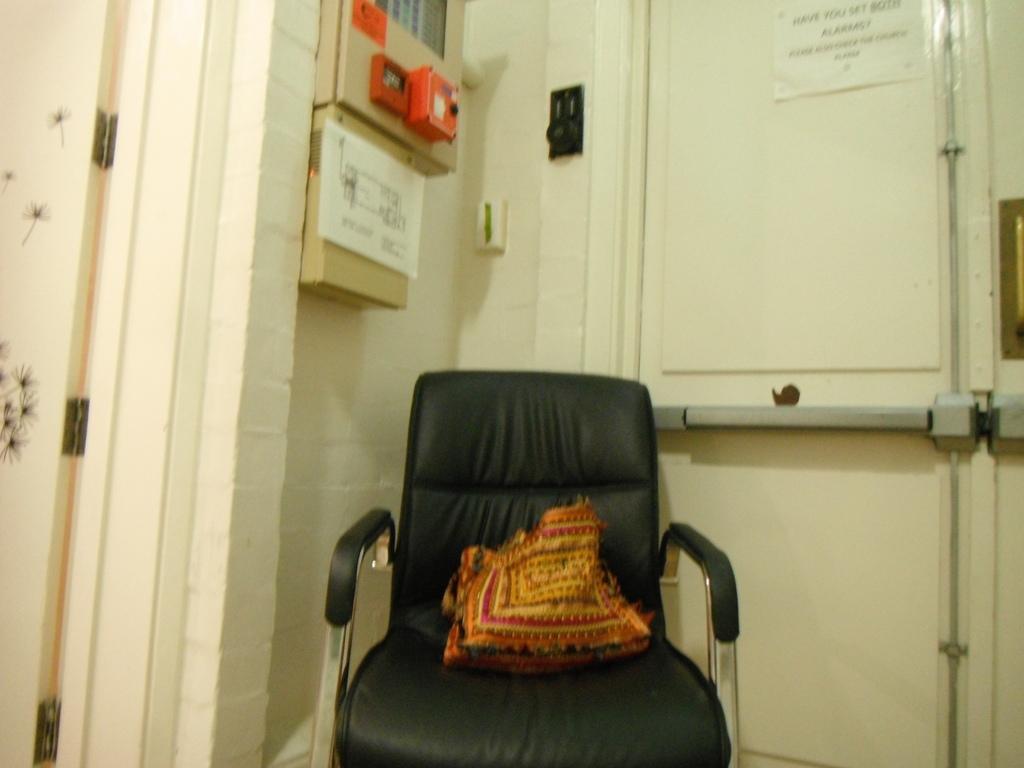Can you describe this image briefly? In this image I can see a black color chair and multi-color object on the chair. Back I can see doors,few boards attached to the cream wall. 